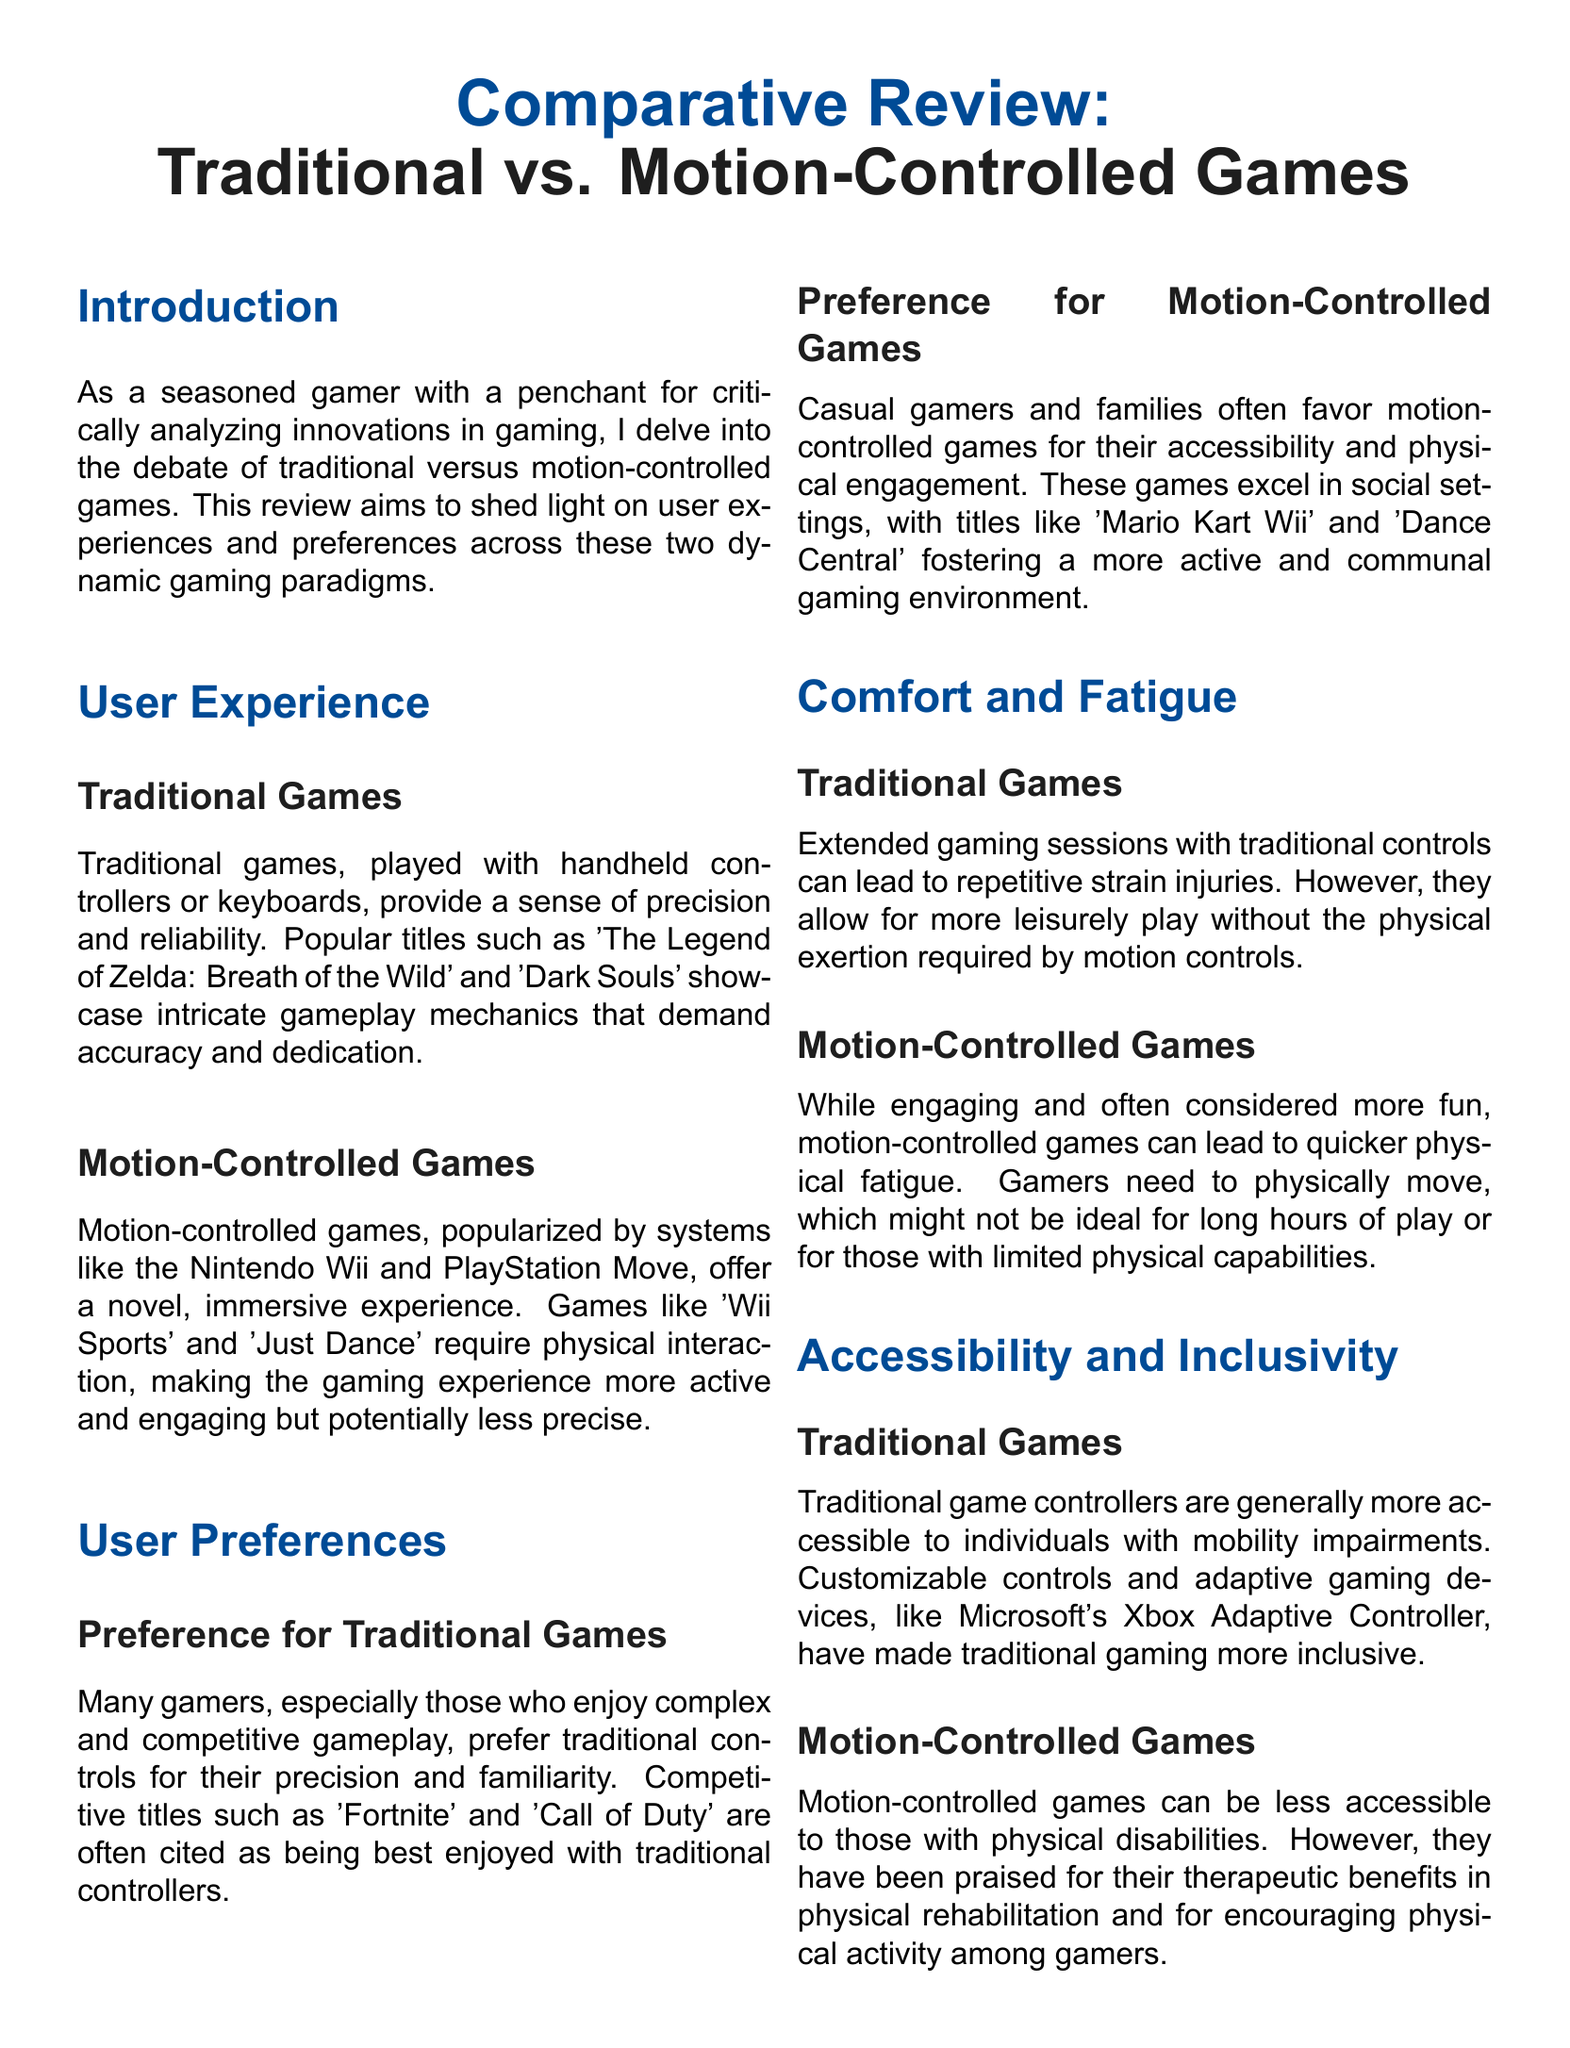What are the popular titles in traditional games? The popular titles mentioned for traditional games include 'The Legend of Zelda: Breath of the Wild' and 'Dark Souls'.
Answer: 'The Legend of Zelda: Breath of the Wild', 'Dark Souls' What gaming systems popularized motion-controlled games? The document states that systems like the Nintendo Wii and PlayStation Move popularized motion-controlled games.
Answer: Nintendo Wii, PlayStation Move Which type of games do competitive gamers prefer? The document indicates that competitive gamers prefer traditional games for their precision and familiarity.
Answer: Traditional games What is a concern for motion-controlled games regarding gameplay duration? Motion-controlled games can lead to quicker physical fatigue during extended play sessions.
Answer: Quicker physical fatigue Which controller has made traditional gaming more inclusive? Microsoft's Xbox Adaptive Controller is mentioned as making traditional gaming more inclusive.
Answer: Xbox Adaptive Controller What type of gamers favor motion-controlled games? Casual gamers and families are indicated as favoring motion-controlled games.
Answer: Casual gamers and families What is a physical drawback of traditional games? The document notes that traditional games can lead to repetitive strain injuries during extended sessions.
Answer: Repetitive strain injuries What do motion-controlled games excel in? Motion-controlled games excel in fostering a more active and communal gaming environment.
Answer: Fostering a more active and communal gaming environment What type of play do traditional games allow for? Traditional games allow for more leisurely play compared to motion-controlled games.
Answer: More leisurely play What benefits of motion-controlled games are mentioned for rehabilitation? Motion-controlled games are praised for their therapeutic benefits in physical rehabilitation.
Answer: Therapeutic benefits in physical rehabilitation 